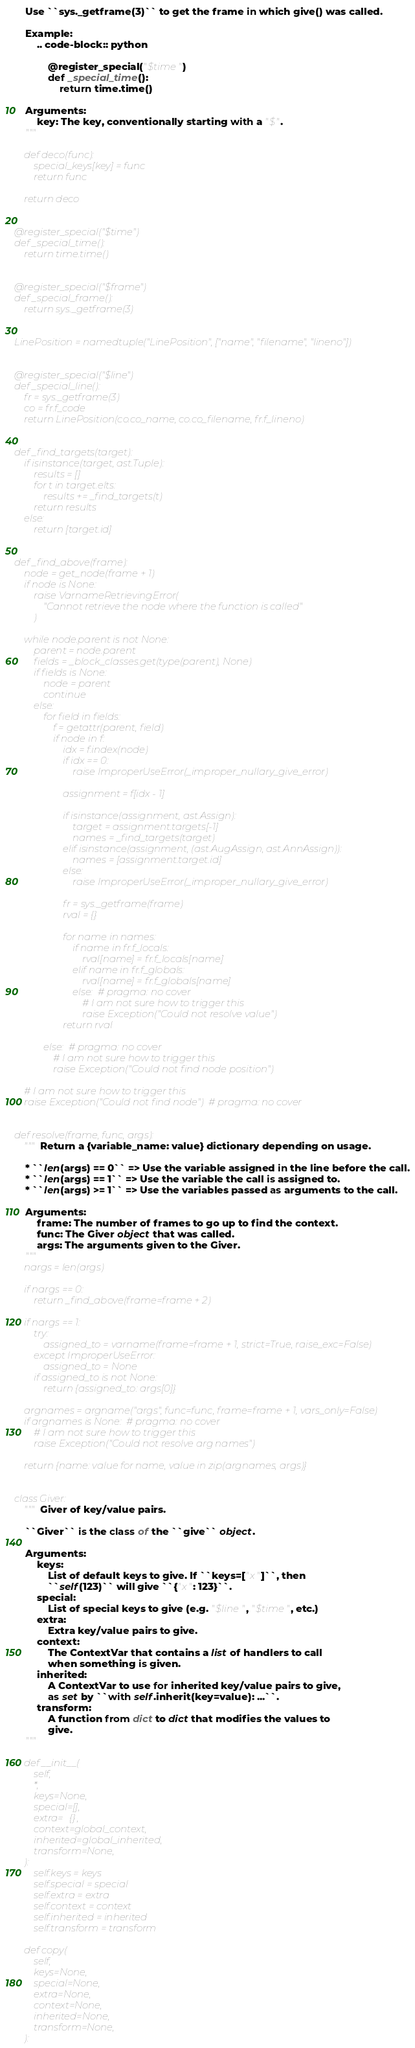<code> <loc_0><loc_0><loc_500><loc_500><_Python_>
    Use ``sys._getframe(3)`` to get the frame in which give() was called.

    Example:
        .. code-block:: python

            @register_special("$time")
            def _special_time():
                return time.time()

    Arguments:
        key: The key, conventionally starting with a "$".
    """

    def deco(func):
        special_keys[key] = func
        return func

    return deco


@register_special("$time")
def _special_time():
    return time.time()


@register_special("$frame")
def _special_frame():
    return sys._getframe(3)


LinePosition = namedtuple("LinePosition", ["name", "filename", "lineno"])


@register_special("$line")
def _special_line():
    fr = sys._getframe(3)
    co = fr.f_code
    return LinePosition(co.co_name, co.co_filename, fr.f_lineno)


def _find_targets(target):
    if isinstance(target, ast.Tuple):
        results = []
        for t in target.elts:
            results += _find_targets(t)
        return results
    else:
        return [target.id]


def _find_above(frame):
    node = get_node(frame + 1)
    if node is None:
        raise VarnameRetrievingError(
            "Cannot retrieve the node where the function is called"
        )

    while node.parent is not None:
        parent = node.parent
        fields = _block_classes.get(type(parent), None)
        if fields is None:
            node = parent
            continue
        else:
            for field in fields:
                f = getattr(parent, field)
                if node in f:
                    idx = f.index(node)
                    if idx == 0:
                        raise ImproperUseError(_improper_nullary_give_error)

                    assignment = f[idx - 1]

                    if isinstance(assignment, ast.Assign):
                        target = assignment.targets[-1]
                        names = _find_targets(target)
                    elif isinstance(assignment, (ast.AugAssign, ast.AnnAssign)):
                        names = [assignment.target.id]
                    else:
                        raise ImproperUseError(_improper_nullary_give_error)

                    fr = sys._getframe(frame)
                    rval = {}

                    for name in names:
                        if name in fr.f_locals:
                            rval[name] = fr.f_locals[name]
                        elif name in fr.f_globals:
                            rval[name] = fr.f_globals[name]
                        else:  # pragma: no cover
                            # I am not sure how to trigger this
                            raise Exception("Could not resolve value")
                    return rval

            else:  # pragma: no cover
                # I am not sure how to trigger this
                raise Exception("Could not find node position")

    # I am not sure how to trigger this
    raise Exception("Could not find node")  # pragma: no cover


def resolve(frame, func, args):
    """Return a {variable_name: value} dictionary depending on usage.

    * ``len(args) == 0`` => Use the variable assigned in the line before the call.
    * ``len(args) == 1`` => Use the variable the call is assigned to.
    * ``len(args) >= 1`` => Use the variables passed as arguments to the call.

    Arguments:
        frame: The number of frames to go up to find the context.
        func: The Giver object that was called.
        args: The arguments given to the Giver.
    """
    nargs = len(args)

    if nargs == 0:
        return _find_above(frame=frame + 2)

    if nargs == 1:
        try:
            assigned_to = varname(frame=frame + 1, strict=True, raise_exc=False)
        except ImproperUseError:
            assigned_to = None
        if assigned_to is not None:
            return {assigned_to: args[0]}

    argnames = argname("args", func=func, frame=frame + 1, vars_only=False)
    if argnames is None:  # pragma: no cover
        # I am not sure how to trigger this
        raise Exception("Could not resolve arg names")

    return {name: value for name, value in zip(argnames, args)}


class Giver:
    """Giver of key/value pairs.

    ``Giver`` is the class of the ``give`` object.

    Arguments:
        keys:
            List of default keys to give. If ``keys=["x"]``, then
            ``self(123)`` will give ``{"x": 123}``.
        special:
            List of special keys to give (e.g. "$line", "$time", etc.)
        extra:
            Extra key/value pairs to give.
        context:
            The ContextVar that contains a list of handlers to call
            when something is given.
        inherited:
            A ContextVar to use for inherited key/value pairs to give,
            as set by ``with self.inherit(key=value): ...``.
        transform:
            A function from dict to dict that modifies the values to
            give.
    """

    def __init__(
        self,
        *,
        keys=None,
        special=[],
        extra={},
        context=global_context,
        inherited=global_inherited,
        transform=None,
    ):
        self.keys = keys
        self.special = special
        self.extra = extra
        self.context = context
        self.inherited = inherited
        self.transform = transform

    def copy(
        self,
        keys=None,
        special=None,
        extra=None,
        context=None,
        inherited=None,
        transform=None,
    ):</code> 